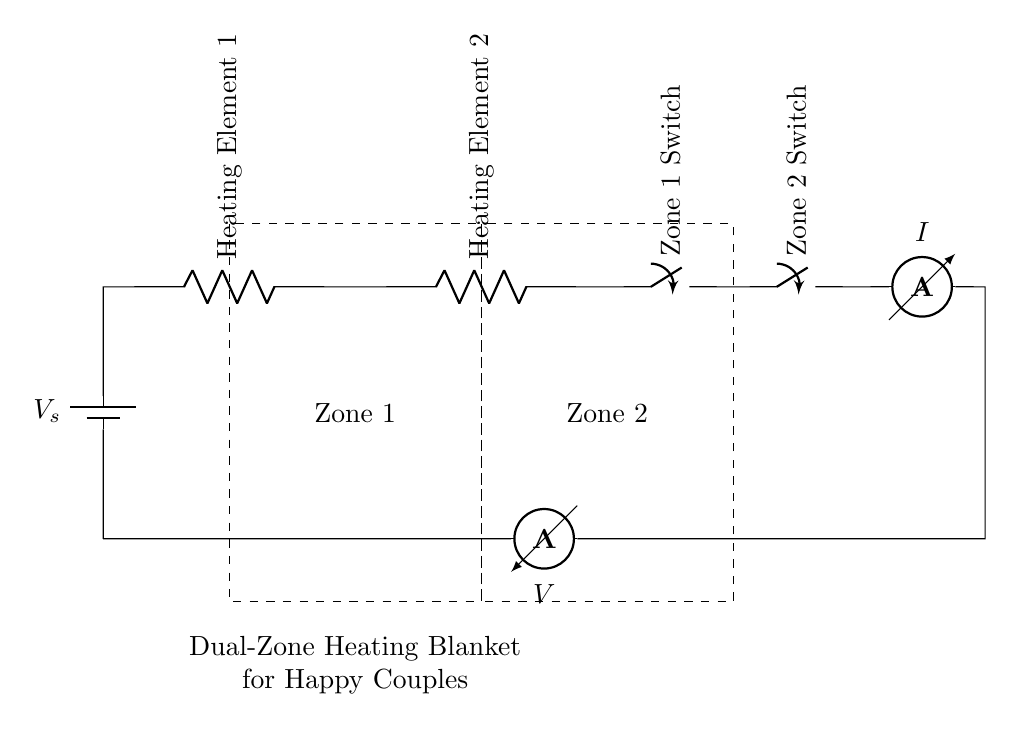What components are present in the circuit? The diagram shows a battery, two heating elements, two switches, an ammeter, and a voltmeter. These components are connected in a series configuration.
Answer: Battery, heating elements, switches, ammeter, voltmeter What does the ammeter measure in this circuit? The ammeter measures the current flowing through the circuit, which is the same for all components since it is a series circuit.
Answer: Current How many heating elements are used in this dual-zone blanket? The circuit diagram specifies two heating elements, indicated clearly in the setup.
Answer: Two What is the function of the switches in this circuit? The switches allow control over each heating zone, enabling one or both zones to be activated or deactivated independently.
Answer: Control heating zones If both heating elements are activated, how does this affect the current? The current remains constant throughout the series circuit; however, the total resistance increases with both elements. This may lead to a difference in voltage across each heating element.
Answer: Current remains constant What is the significance of the dashed rectangles in the circuit? The dashed rectangles indicate separate zones, which show that the circuit is designed to accommodate two independent heating areas for couples. This visual distinction is important for understanding operational control.
Answer: Separate heating zones Which component indicates the voltage in the circuit? The voltmeter is used to measure the voltage across the entire circuit, allowing for an understanding of the electrical potential difference present.
Answer: Voltmeter 